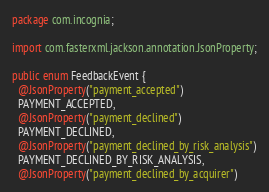Convert code to text. <code><loc_0><loc_0><loc_500><loc_500><_Java_>package com.incognia;

import com.fasterxml.jackson.annotation.JsonProperty;

public enum FeedbackEvent {
  @JsonProperty("payment_accepted")
  PAYMENT_ACCEPTED,
  @JsonProperty("payment_declined")
  PAYMENT_DECLINED,
  @JsonProperty("payment_declined_by_risk_analysis")
  PAYMENT_DECLINED_BY_RISK_ANALYSIS,
  @JsonProperty("payment_declined_by_acquirer")</code> 